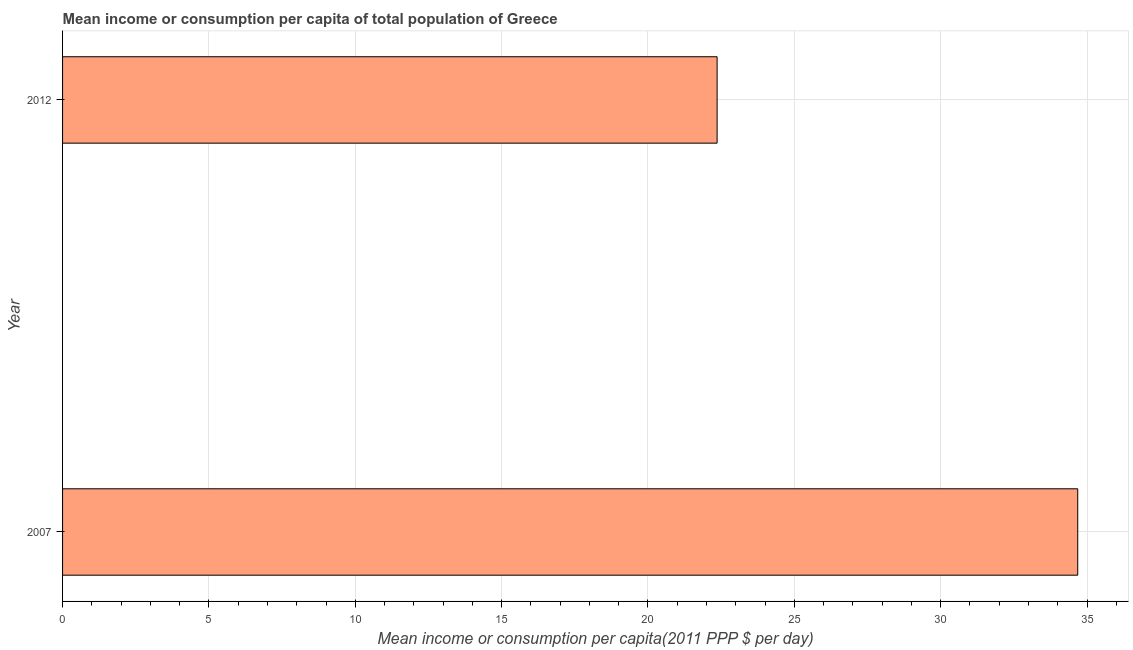Does the graph contain any zero values?
Your answer should be very brief. No. What is the title of the graph?
Give a very brief answer. Mean income or consumption per capita of total population of Greece. What is the label or title of the X-axis?
Offer a very short reply. Mean income or consumption per capita(2011 PPP $ per day). What is the mean income or consumption in 2012?
Your answer should be compact. 22.36. Across all years, what is the maximum mean income or consumption?
Offer a terse response. 34.68. Across all years, what is the minimum mean income or consumption?
Provide a short and direct response. 22.36. In which year was the mean income or consumption maximum?
Ensure brevity in your answer.  2007. What is the sum of the mean income or consumption?
Offer a very short reply. 57.04. What is the difference between the mean income or consumption in 2007 and 2012?
Your answer should be compact. 12.32. What is the average mean income or consumption per year?
Keep it short and to the point. 28.52. What is the median mean income or consumption?
Your response must be concise. 28.52. What is the ratio of the mean income or consumption in 2007 to that in 2012?
Give a very brief answer. 1.55. Is the mean income or consumption in 2007 less than that in 2012?
Your answer should be very brief. No. Are all the bars in the graph horizontal?
Provide a short and direct response. Yes. What is the difference between two consecutive major ticks on the X-axis?
Offer a terse response. 5. Are the values on the major ticks of X-axis written in scientific E-notation?
Offer a very short reply. No. What is the Mean income or consumption per capita(2011 PPP $ per day) in 2007?
Offer a very short reply. 34.68. What is the Mean income or consumption per capita(2011 PPP $ per day) of 2012?
Provide a succinct answer. 22.36. What is the difference between the Mean income or consumption per capita(2011 PPP $ per day) in 2007 and 2012?
Give a very brief answer. 12.32. What is the ratio of the Mean income or consumption per capita(2011 PPP $ per day) in 2007 to that in 2012?
Give a very brief answer. 1.55. 